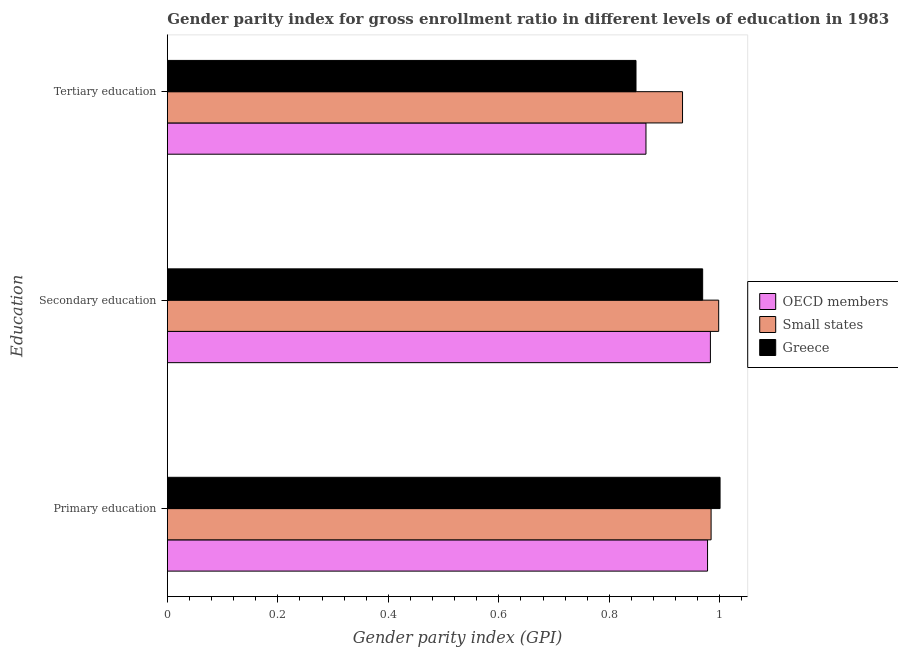How many groups of bars are there?
Make the answer very short. 3. What is the label of the 2nd group of bars from the top?
Make the answer very short. Secondary education. What is the gender parity index in tertiary education in Small states?
Give a very brief answer. 0.93. Across all countries, what is the maximum gender parity index in tertiary education?
Your answer should be very brief. 0.93. Across all countries, what is the minimum gender parity index in secondary education?
Your response must be concise. 0.97. In which country was the gender parity index in primary education maximum?
Provide a short and direct response. Greece. What is the total gender parity index in primary education in the graph?
Provide a short and direct response. 2.96. What is the difference between the gender parity index in tertiary education in OECD members and that in Small states?
Provide a short and direct response. -0.07. What is the difference between the gender parity index in secondary education in Small states and the gender parity index in primary education in Greece?
Offer a very short reply. -0. What is the average gender parity index in secondary education per country?
Ensure brevity in your answer.  0.98. What is the difference between the gender parity index in primary education and gender parity index in tertiary education in OECD members?
Provide a short and direct response. 0.11. What is the ratio of the gender parity index in secondary education in Small states to that in Greece?
Ensure brevity in your answer.  1.03. Is the gender parity index in secondary education in Small states less than that in OECD members?
Your response must be concise. No. What is the difference between the highest and the second highest gender parity index in primary education?
Give a very brief answer. 0.02. What is the difference between the highest and the lowest gender parity index in secondary education?
Offer a very short reply. 0.03. Is the sum of the gender parity index in primary education in OECD members and Small states greater than the maximum gender parity index in tertiary education across all countries?
Offer a terse response. Yes. What does the 2nd bar from the top in Primary education represents?
Ensure brevity in your answer.  Small states. What does the 2nd bar from the bottom in Primary education represents?
Provide a short and direct response. Small states. Are all the bars in the graph horizontal?
Offer a terse response. Yes. Are the values on the major ticks of X-axis written in scientific E-notation?
Keep it short and to the point. No. Does the graph contain any zero values?
Your response must be concise. No. Does the graph contain grids?
Your answer should be very brief. No. Where does the legend appear in the graph?
Provide a short and direct response. Center right. What is the title of the graph?
Keep it short and to the point. Gender parity index for gross enrollment ratio in different levels of education in 1983. What is the label or title of the X-axis?
Your answer should be compact. Gender parity index (GPI). What is the label or title of the Y-axis?
Provide a short and direct response. Education. What is the Gender parity index (GPI) in OECD members in Primary education?
Your response must be concise. 0.98. What is the Gender parity index (GPI) of Small states in Primary education?
Make the answer very short. 0.98. What is the Gender parity index (GPI) of Greece in Primary education?
Your answer should be compact. 1. What is the Gender parity index (GPI) of OECD members in Secondary education?
Your response must be concise. 0.98. What is the Gender parity index (GPI) in Small states in Secondary education?
Your response must be concise. 1. What is the Gender parity index (GPI) of Greece in Secondary education?
Ensure brevity in your answer.  0.97. What is the Gender parity index (GPI) of OECD members in Tertiary education?
Your response must be concise. 0.87. What is the Gender parity index (GPI) in Small states in Tertiary education?
Offer a terse response. 0.93. What is the Gender parity index (GPI) in Greece in Tertiary education?
Offer a very short reply. 0.85. Across all Education, what is the maximum Gender parity index (GPI) in OECD members?
Your answer should be compact. 0.98. Across all Education, what is the maximum Gender parity index (GPI) in Small states?
Keep it short and to the point. 1. Across all Education, what is the maximum Gender parity index (GPI) in Greece?
Provide a succinct answer. 1. Across all Education, what is the minimum Gender parity index (GPI) of OECD members?
Keep it short and to the point. 0.87. Across all Education, what is the minimum Gender parity index (GPI) of Small states?
Make the answer very short. 0.93. Across all Education, what is the minimum Gender parity index (GPI) in Greece?
Your response must be concise. 0.85. What is the total Gender parity index (GPI) of OECD members in the graph?
Provide a short and direct response. 2.83. What is the total Gender parity index (GPI) in Small states in the graph?
Your response must be concise. 2.91. What is the total Gender parity index (GPI) in Greece in the graph?
Make the answer very short. 2.82. What is the difference between the Gender parity index (GPI) of OECD members in Primary education and that in Secondary education?
Provide a succinct answer. -0.01. What is the difference between the Gender parity index (GPI) in Small states in Primary education and that in Secondary education?
Offer a very short reply. -0.01. What is the difference between the Gender parity index (GPI) of Greece in Primary education and that in Secondary education?
Ensure brevity in your answer.  0.03. What is the difference between the Gender parity index (GPI) of OECD members in Primary education and that in Tertiary education?
Provide a short and direct response. 0.11. What is the difference between the Gender parity index (GPI) of Small states in Primary education and that in Tertiary education?
Ensure brevity in your answer.  0.05. What is the difference between the Gender parity index (GPI) in Greece in Primary education and that in Tertiary education?
Provide a short and direct response. 0.15. What is the difference between the Gender parity index (GPI) of OECD members in Secondary education and that in Tertiary education?
Your response must be concise. 0.12. What is the difference between the Gender parity index (GPI) of Small states in Secondary education and that in Tertiary education?
Your response must be concise. 0.07. What is the difference between the Gender parity index (GPI) of Greece in Secondary education and that in Tertiary education?
Provide a short and direct response. 0.12. What is the difference between the Gender parity index (GPI) of OECD members in Primary education and the Gender parity index (GPI) of Small states in Secondary education?
Your answer should be compact. -0.02. What is the difference between the Gender parity index (GPI) in OECD members in Primary education and the Gender parity index (GPI) in Greece in Secondary education?
Your answer should be very brief. 0.01. What is the difference between the Gender parity index (GPI) of Small states in Primary education and the Gender parity index (GPI) of Greece in Secondary education?
Offer a terse response. 0.02. What is the difference between the Gender parity index (GPI) of OECD members in Primary education and the Gender parity index (GPI) of Small states in Tertiary education?
Provide a succinct answer. 0.05. What is the difference between the Gender parity index (GPI) in OECD members in Primary education and the Gender parity index (GPI) in Greece in Tertiary education?
Your answer should be very brief. 0.13. What is the difference between the Gender parity index (GPI) in Small states in Primary education and the Gender parity index (GPI) in Greece in Tertiary education?
Your answer should be very brief. 0.14. What is the difference between the Gender parity index (GPI) in OECD members in Secondary education and the Gender parity index (GPI) in Small states in Tertiary education?
Your answer should be compact. 0.05. What is the difference between the Gender parity index (GPI) of OECD members in Secondary education and the Gender parity index (GPI) of Greece in Tertiary education?
Keep it short and to the point. 0.13. What is the difference between the Gender parity index (GPI) of Small states in Secondary education and the Gender parity index (GPI) of Greece in Tertiary education?
Ensure brevity in your answer.  0.15. What is the average Gender parity index (GPI) of OECD members per Education?
Provide a short and direct response. 0.94. What is the average Gender parity index (GPI) in Small states per Education?
Give a very brief answer. 0.97. What is the average Gender parity index (GPI) of Greece per Education?
Make the answer very short. 0.94. What is the difference between the Gender parity index (GPI) of OECD members and Gender parity index (GPI) of Small states in Primary education?
Your answer should be very brief. -0.01. What is the difference between the Gender parity index (GPI) in OECD members and Gender parity index (GPI) in Greece in Primary education?
Offer a terse response. -0.02. What is the difference between the Gender parity index (GPI) of Small states and Gender parity index (GPI) of Greece in Primary education?
Offer a terse response. -0.02. What is the difference between the Gender parity index (GPI) of OECD members and Gender parity index (GPI) of Small states in Secondary education?
Keep it short and to the point. -0.01. What is the difference between the Gender parity index (GPI) in OECD members and Gender parity index (GPI) in Greece in Secondary education?
Keep it short and to the point. 0.01. What is the difference between the Gender parity index (GPI) of Small states and Gender parity index (GPI) of Greece in Secondary education?
Offer a very short reply. 0.03. What is the difference between the Gender parity index (GPI) in OECD members and Gender parity index (GPI) in Small states in Tertiary education?
Your answer should be very brief. -0.07. What is the difference between the Gender parity index (GPI) in OECD members and Gender parity index (GPI) in Greece in Tertiary education?
Your response must be concise. 0.02. What is the difference between the Gender parity index (GPI) in Small states and Gender parity index (GPI) in Greece in Tertiary education?
Your response must be concise. 0.08. What is the ratio of the Gender parity index (GPI) of Small states in Primary education to that in Secondary education?
Your response must be concise. 0.99. What is the ratio of the Gender parity index (GPI) in Greece in Primary education to that in Secondary education?
Give a very brief answer. 1.03. What is the ratio of the Gender parity index (GPI) in OECD members in Primary education to that in Tertiary education?
Offer a terse response. 1.13. What is the ratio of the Gender parity index (GPI) of Small states in Primary education to that in Tertiary education?
Your answer should be very brief. 1.06. What is the ratio of the Gender parity index (GPI) in Greece in Primary education to that in Tertiary education?
Keep it short and to the point. 1.18. What is the ratio of the Gender parity index (GPI) in OECD members in Secondary education to that in Tertiary education?
Keep it short and to the point. 1.13. What is the ratio of the Gender parity index (GPI) of Small states in Secondary education to that in Tertiary education?
Provide a succinct answer. 1.07. What is the ratio of the Gender parity index (GPI) in Greece in Secondary education to that in Tertiary education?
Ensure brevity in your answer.  1.14. What is the difference between the highest and the second highest Gender parity index (GPI) of OECD members?
Provide a short and direct response. 0.01. What is the difference between the highest and the second highest Gender parity index (GPI) in Small states?
Ensure brevity in your answer.  0.01. What is the difference between the highest and the second highest Gender parity index (GPI) of Greece?
Your answer should be very brief. 0.03. What is the difference between the highest and the lowest Gender parity index (GPI) of OECD members?
Keep it short and to the point. 0.12. What is the difference between the highest and the lowest Gender parity index (GPI) of Small states?
Your response must be concise. 0.07. What is the difference between the highest and the lowest Gender parity index (GPI) in Greece?
Your answer should be very brief. 0.15. 